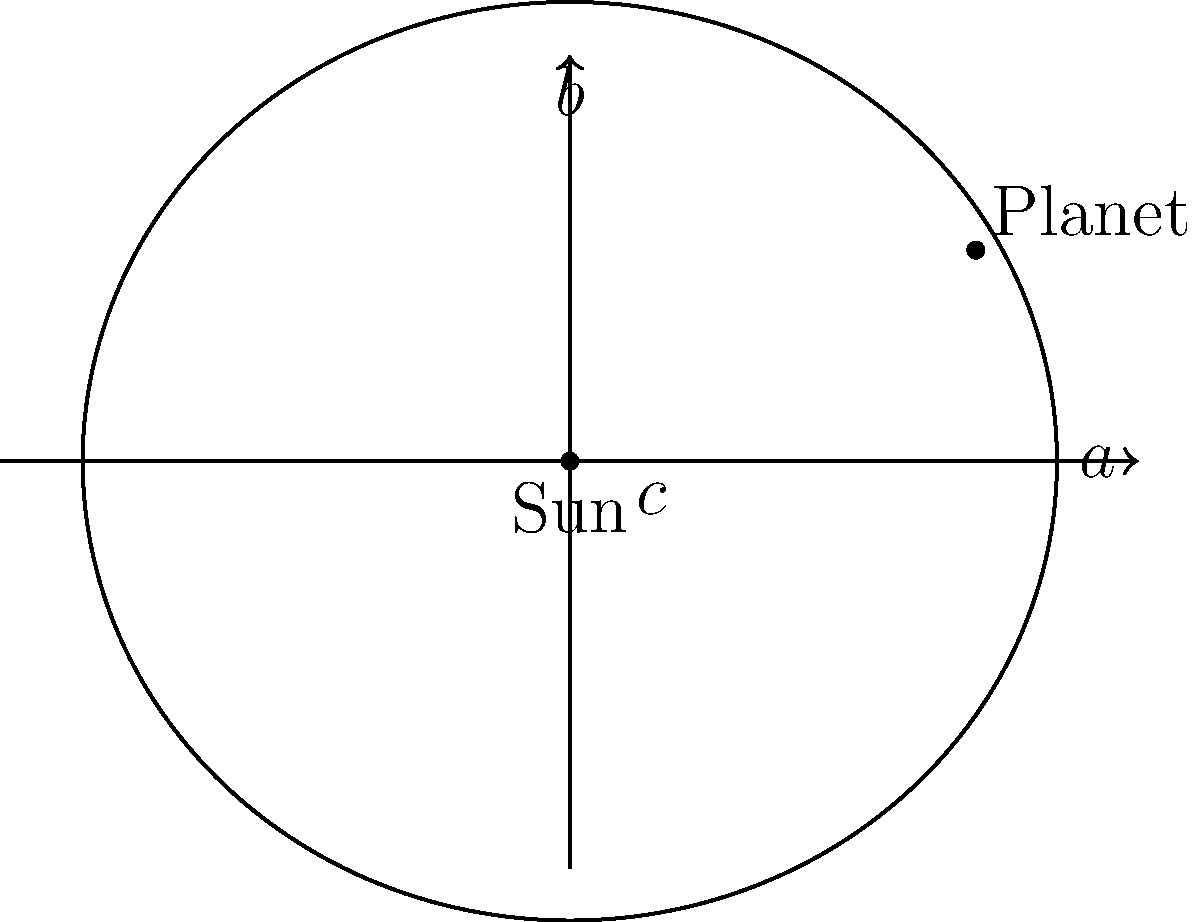Considerando a órbita elíptica de um planeta ao redor do Sol, como mostrado na figura, e sabendo que $a$ é o semi-eixo maior, $b$ é o semi-eixo menor, e $c$ é a distância do centro ao foco, qual é a relação matemática entre essas três variáveis que define a excentricidade ($e$) da órbita? Para resolver esta questão, vamos seguir os seguintes passos:

1) A excentricidade ($e$) de uma elipse é uma medida de quão "achatada" ela é em comparação com um círculo perfeito.

2) Em uma elipse, a excentricidade é definida como a razão entre a distância focal ($2c$) e o eixo maior ($2a$):

   $$e = \frac{c}{a}$$

3) O teorema de Pitágoras relaciona $a$, $b$, e $c$ em uma elipse:

   $$a^2 = b^2 + c^2$$

4) Isolando $c^2$:

   $$c^2 = a^2 - b^2$$

5) Tomando a raiz quadrada de ambos os lados:

   $$c = \sqrt{a^2 - b^2}$$

6) Substituindo esta expressão para $c$ na fórmula da excentricidade:

   $$e = \frac{\sqrt{a^2 - b^2}}{a}$$

Esta é a relação matemática que define a excentricidade da órbita em termos de $a$ e $b$.
Answer: $e = \frac{\sqrt{a^2 - b^2}}{a}$ 